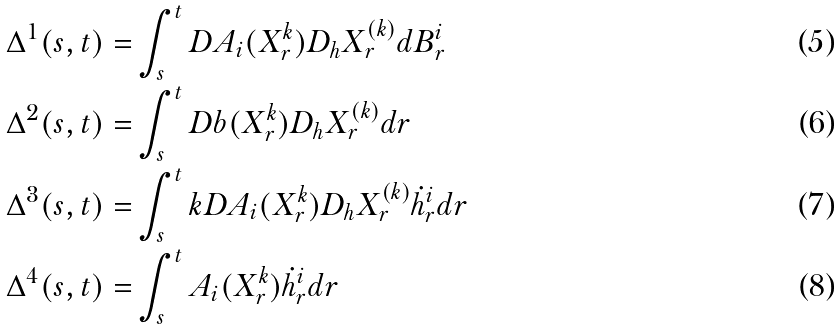Convert formula to latex. <formula><loc_0><loc_0><loc_500><loc_500>\Delta ^ { 1 } ( s , t ) = & \int _ { s } ^ { t } D A _ { i } ( X ^ { k } _ { r } ) D _ { h } X ^ { ( k ) } _ { r } d B ^ { i } _ { r } \\ \Delta ^ { 2 } ( s , t ) = & \int _ { s } ^ { t } D b ( X ^ { k } _ { r } ) D _ { h } X ^ { ( k ) } _ { r } d r \\ \Delta ^ { 3 } ( s , t ) = & \int _ { s } ^ { t } k D A _ { i } ( X ^ { k } _ { r } ) D _ { h } X ^ { ( k ) } _ { r } \dot { h } ^ { i } _ { r } d r \\ \Delta ^ { 4 } ( s , t ) = & \int _ { s } ^ { t } A _ { i } ( X ^ { k } _ { r } ) \dot { h } ^ { i } _ { r } d r</formula> 